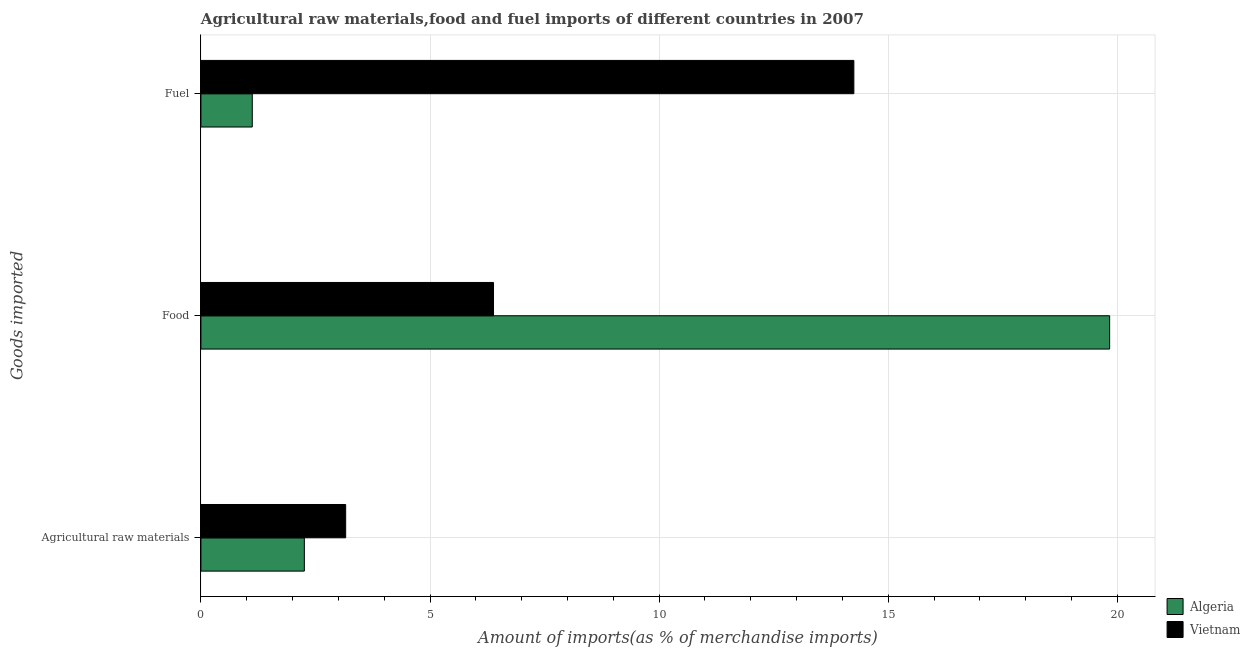How many different coloured bars are there?
Your answer should be very brief. 2. Are the number of bars per tick equal to the number of legend labels?
Make the answer very short. Yes. Are the number of bars on each tick of the Y-axis equal?
Keep it short and to the point. Yes. What is the label of the 1st group of bars from the top?
Offer a terse response. Fuel. What is the percentage of fuel imports in Vietnam?
Provide a succinct answer. 14.25. Across all countries, what is the maximum percentage of raw materials imports?
Your answer should be compact. 3.16. Across all countries, what is the minimum percentage of food imports?
Provide a short and direct response. 6.39. In which country was the percentage of fuel imports maximum?
Make the answer very short. Vietnam. In which country was the percentage of food imports minimum?
Provide a succinct answer. Vietnam. What is the total percentage of raw materials imports in the graph?
Give a very brief answer. 5.42. What is the difference between the percentage of fuel imports in Algeria and that in Vietnam?
Your answer should be very brief. -13.13. What is the difference between the percentage of fuel imports in Vietnam and the percentage of food imports in Algeria?
Offer a terse response. -5.58. What is the average percentage of food imports per country?
Offer a terse response. 13.11. What is the difference between the percentage of fuel imports and percentage of food imports in Vietnam?
Offer a terse response. 7.86. What is the ratio of the percentage of food imports in Algeria to that in Vietnam?
Ensure brevity in your answer.  3.11. Is the difference between the percentage of fuel imports in Algeria and Vietnam greater than the difference between the percentage of raw materials imports in Algeria and Vietnam?
Offer a very short reply. No. What is the difference between the highest and the second highest percentage of food imports?
Provide a succinct answer. 13.45. What is the difference between the highest and the lowest percentage of raw materials imports?
Keep it short and to the point. 0.9. In how many countries, is the percentage of food imports greater than the average percentage of food imports taken over all countries?
Your answer should be compact. 1. Is the sum of the percentage of fuel imports in Algeria and Vietnam greater than the maximum percentage of raw materials imports across all countries?
Your answer should be compact. Yes. What does the 2nd bar from the top in Fuel represents?
Your answer should be very brief. Algeria. What does the 1st bar from the bottom in Fuel represents?
Ensure brevity in your answer.  Algeria. What is the difference between two consecutive major ticks on the X-axis?
Your answer should be compact. 5. Are the values on the major ticks of X-axis written in scientific E-notation?
Your answer should be very brief. No. Does the graph contain any zero values?
Provide a short and direct response. No. How many legend labels are there?
Your answer should be very brief. 2. What is the title of the graph?
Offer a very short reply. Agricultural raw materials,food and fuel imports of different countries in 2007. What is the label or title of the X-axis?
Provide a short and direct response. Amount of imports(as % of merchandise imports). What is the label or title of the Y-axis?
Give a very brief answer. Goods imported. What is the Amount of imports(as % of merchandise imports) of Algeria in Agricultural raw materials?
Keep it short and to the point. 2.26. What is the Amount of imports(as % of merchandise imports) of Vietnam in Agricultural raw materials?
Make the answer very short. 3.16. What is the Amount of imports(as % of merchandise imports) in Algeria in Food?
Ensure brevity in your answer.  19.83. What is the Amount of imports(as % of merchandise imports) of Vietnam in Food?
Offer a terse response. 6.39. What is the Amount of imports(as % of merchandise imports) in Algeria in Fuel?
Your answer should be compact. 1.12. What is the Amount of imports(as % of merchandise imports) in Vietnam in Fuel?
Your answer should be compact. 14.25. Across all Goods imported, what is the maximum Amount of imports(as % of merchandise imports) in Algeria?
Your response must be concise. 19.83. Across all Goods imported, what is the maximum Amount of imports(as % of merchandise imports) of Vietnam?
Provide a short and direct response. 14.25. Across all Goods imported, what is the minimum Amount of imports(as % of merchandise imports) of Algeria?
Make the answer very short. 1.12. Across all Goods imported, what is the minimum Amount of imports(as % of merchandise imports) of Vietnam?
Your response must be concise. 3.16. What is the total Amount of imports(as % of merchandise imports) in Algeria in the graph?
Keep it short and to the point. 23.21. What is the total Amount of imports(as % of merchandise imports) in Vietnam in the graph?
Offer a very short reply. 23.79. What is the difference between the Amount of imports(as % of merchandise imports) in Algeria in Agricultural raw materials and that in Food?
Offer a terse response. -17.58. What is the difference between the Amount of imports(as % of merchandise imports) of Vietnam in Agricultural raw materials and that in Food?
Ensure brevity in your answer.  -3.23. What is the difference between the Amount of imports(as % of merchandise imports) in Algeria in Agricultural raw materials and that in Fuel?
Keep it short and to the point. 1.14. What is the difference between the Amount of imports(as % of merchandise imports) in Vietnam in Agricultural raw materials and that in Fuel?
Your answer should be compact. -11.09. What is the difference between the Amount of imports(as % of merchandise imports) of Algeria in Food and that in Fuel?
Offer a terse response. 18.71. What is the difference between the Amount of imports(as % of merchandise imports) of Vietnam in Food and that in Fuel?
Your answer should be very brief. -7.86. What is the difference between the Amount of imports(as % of merchandise imports) of Algeria in Agricultural raw materials and the Amount of imports(as % of merchandise imports) of Vietnam in Food?
Offer a very short reply. -4.13. What is the difference between the Amount of imports(as % of merchandise imports) in Algeria in Agricultural raw materials and the Amount of imports(as % of merchandise imports) in Vietnam in Fuel?
Your response must be concise. -11.99. What is the difference between the Amount of imports(as % of merchandise imports) of Algeria in Food and the Amount of imports(as % of merchandise imports) of Vietnam in Fuel?
Your response must be concise. 5.58. What is the average Amount of imports(as % of merchandise imports) of Algeria per Goods imported?
Give a very brief answer. 7.74. What is the average Amount of imports(as % of merchandise imports) in Vietnam per Goods imported?
Provide a short and direct response. 7.93. What is the difference between the Amount of imports(as % of merchandise imports) in Algeria and Amount of imports(as % of merchandise imports) in Vietnam in Agricultural raw materials?
Offer a terse response. -0.9. What is the difference between the Amount of imports(as % of merchandise imports) in Algeria and Amount of imports(as % of merchandise imports) in Vietnam in Food?
Offer a very short reply. 13.45. What is the difference between the Amount of imports(as % of merchandise imports) of Algeria and Amount of imports(as % of merchandise imports) of Vietnam in Fuel?
Give a very brief answer. -13.13. What is the ratio of the Amount of imports(as % of merchandise imports) of Algeria in Agricultural raw materials to that in Food?
Keep it short and to the point. 0.11. What is the ratio of the Amount of imports(as % of merchandise imports) of Vietnam in Agricultural raw materials to that in Food?
Offer a very short reply. 0.49. What is the ratio of the Amount of imports(as % of merchandise imports) of Algeria in Agricultural raw materials to that in Fuel?
Provide a succinct answer. 2.01. What is the ratio of the Amount of imports(as % of merchandise imports) in Vietnam in Agricultural raw materials to that in Fuel?
Your answer should be compact. 0.22. What is the ratio of the Amount of imports(as % of merchandise imports) in Algeria in Food to that in Fuel?
Provide a succinct answer. 17.69. What is the ratio of the Amount of imports(as % of merchandise imports) of Vietnam in Food to that in Fuel?
Offer a terse response. 0.45. What is the difference between the highest and the second highest Amount of imports(as % of merchandise imports) in Algeria?
Offer a very short reply. 17.58. What is the difference between the highest and the second highest Amount of imports(as % of merchandise imports) of Vietnam?
Ensure brevity in your answer.  7.86. What is the difference between the highest and the lowest Amount of imports(as % of merchandise imports) of Algeria?
Give a very brief answer. 18.71. What is the difference between the highest and the lowest Amount of imports(as % of merchandise imports) in Vietnam?
Offer a very short reply. 11.09. 